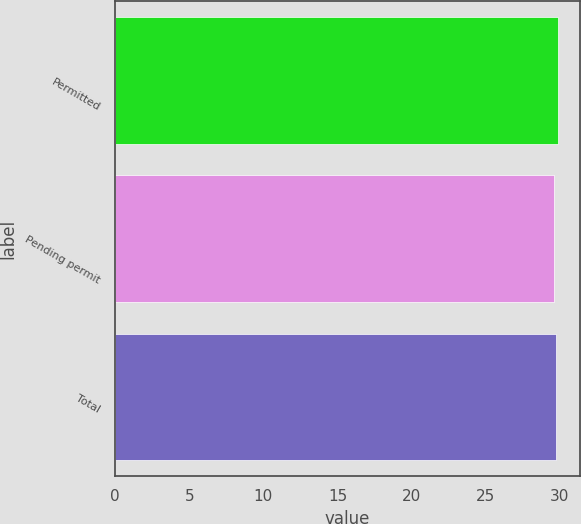<chart> <loc_0><loc_0><loc_500><loc_500><bar_chart><fcel>Permitted<fcel>Pending permit<fcel>Total<nl><fcel>29.84<fcel>29.57<fcel>29.72<nl></chart> 